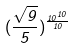Convert formula to latex. <formula><loc_0><loc_0><loc_500><loc_500>( \frac { \sqrt { 9 } } { 5 } ) ^ { \frac { 1 0 ^ { 1 0 } } { 1 0 } }</formula> 